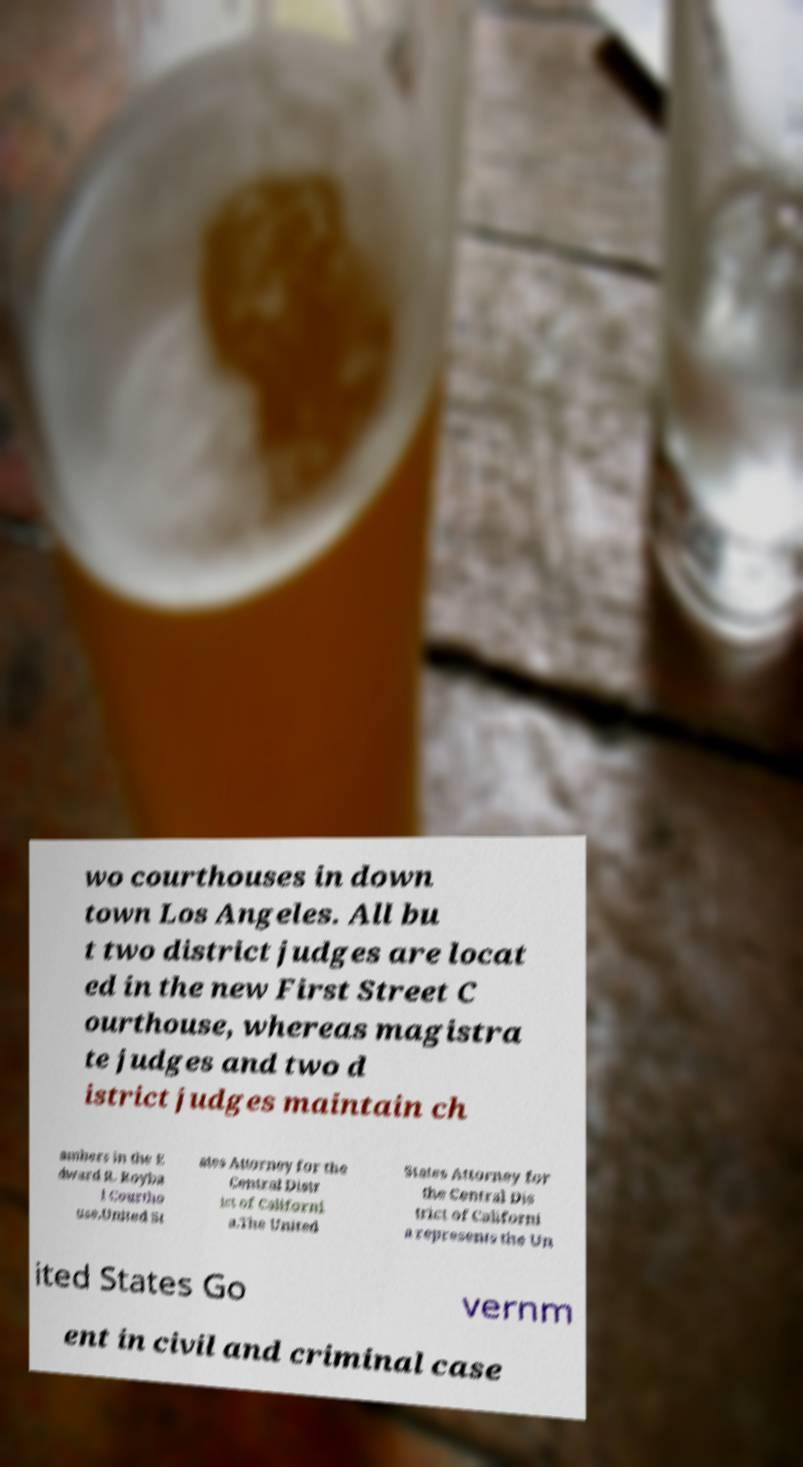What messages or text are displayed in this image? I need them in a readable, typed format. wo courthouses in down town Los Angeles. All bu t two district judges are locat ed in the new First Street C ourthouse, whereas magistra te judges and two d istrict judges maintain ch ambers in the E dward R. Royba l Courtho use.United St ates Attorney for the Central Distr ict of Californi a.The United States Attorney for the Central Dis trict of Californi a represents the Un ited States Go vernm ent in civil and criminal case 